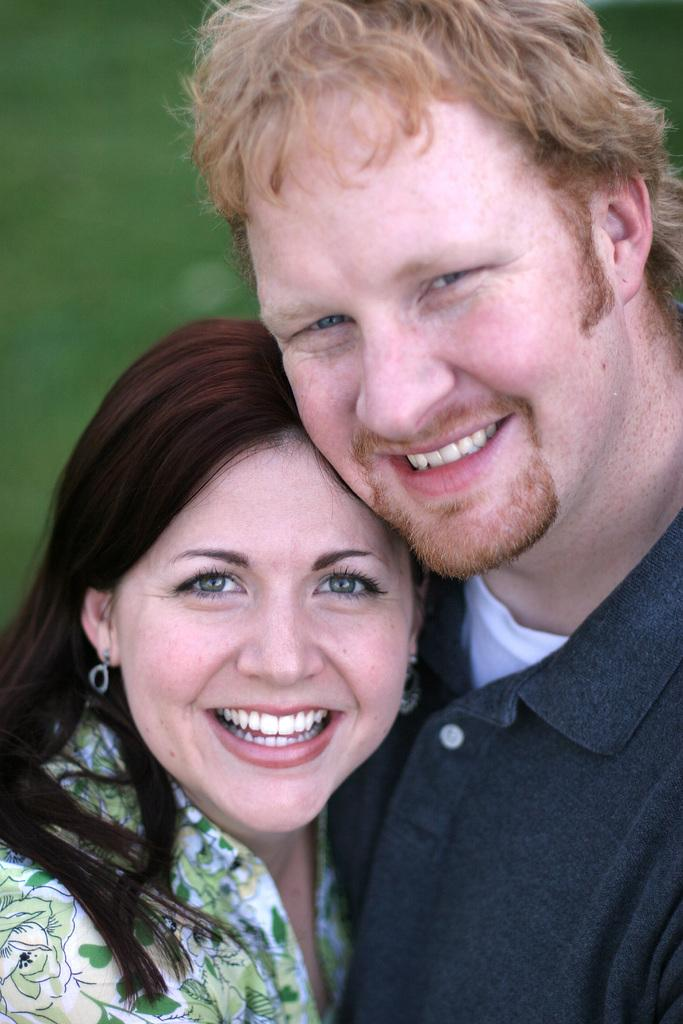Who is present in the image? There is a man and a lady in the image. What are the facial expressions of the people in the image? Both the man and the lady are smiling in the image. What type of mark does the bat leave on the self in the image? There is no bat or self present in the image, so it is not possible to answer that question. 